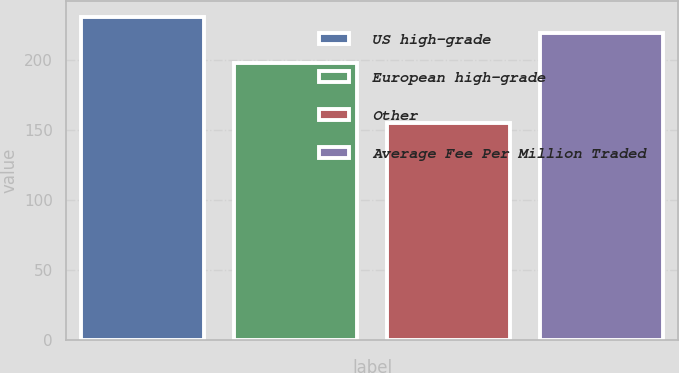Convert chart. <chart><loc_0><loc_0><loc_500><loc_500><bar_chart><fcel>US high-grade<fcel>European high-grade<fcel>Other<fcel>Average Fee Per Million Traded<nl><fcel>231<fcel>198<fcel>155<fcel>219.6<nl></chart> 